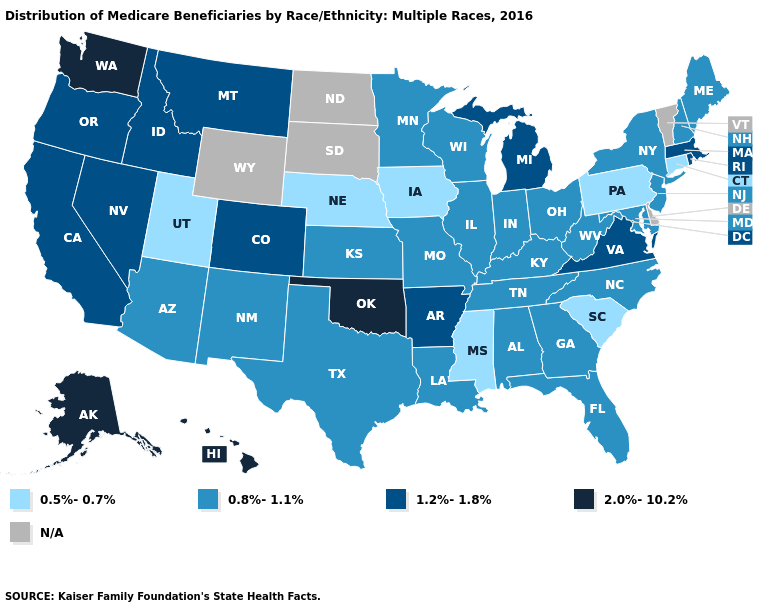Name the states that have a value in the range 1.2%-1.8%?
Short answer required. Arkansas, California, Colorado, Idaho, Massachusetts, Michigan, Montana, Nevada, Oregon, Rhode Island, Virginia. What is the value of New York?
Be succinct. 0.8%-1.1%. What is the lowest value in the Northeast?
Concise answer only. 0.5%-0.7%. Among the states that border Georgia , which have the highest value?
Short answer required. Alabama, Florida, North Carolina, Tennessee. Does the map have missing data?
Quick response, please. Yes. Name the states that have a value in the range 0.8%-1.1%?
Quick response, please. Alabama, Arizona, Florida, Georgia, Illinois, Indiana, Kansas, Kentucky, Louisiana, Maine, Maryland, Minnesota, Missouri, New Hampshire, New Jersey, New Mexico, New York, North Carolina, Ohio, Tennessee, Texas, West Virginia, Wisconsin. Does Hawaii have the highest value in the USA?
Concise answer only. Yes. Does Mississippi have the lowest value in the USA?
Write a very short answer. Yes. Does Iowa have the lowest value in the USA?
Give a very brief answer. Yes. Name the states that have a value in the range 2.0%-10.2%?
Short answer required. Alaska, Hawaii, Oklahoma, Washington. What is the value of Pennsylvania?
Answer briefly. 0.5%-0.7%. Does New Jersey have the lowest value in the Northeast?
Write a very short answer. No. What is the value of South Carolina?
Keep it brief. 0.5%-0.7%. Does the map have missing data?
Answer briefly. Yes. 